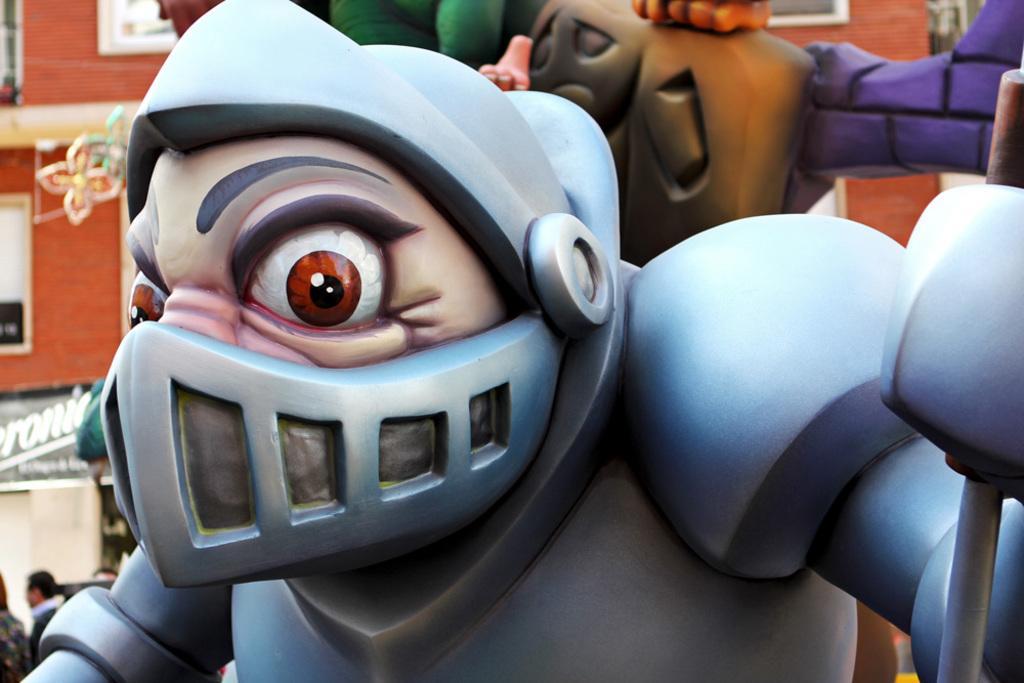Describe this image in one or two sentences. In this image there are toys, on the left there is a building and a man. 